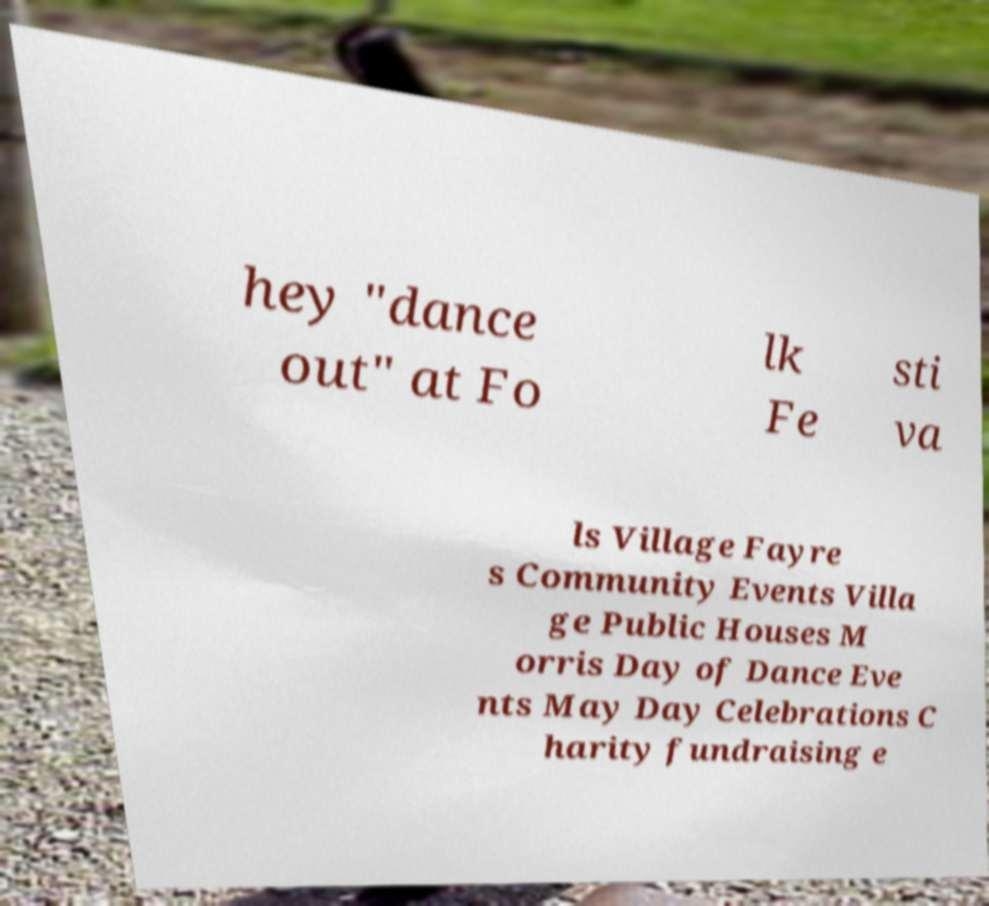Can you accurately transcribe the text from the provided image for me? hey "dance out" at Fo lk Fe sti va ls Village Fayre s Community Events Villa ge Public Houses M orris Day of Dance Eve nts May Day Celebrations C harity fundraising e 